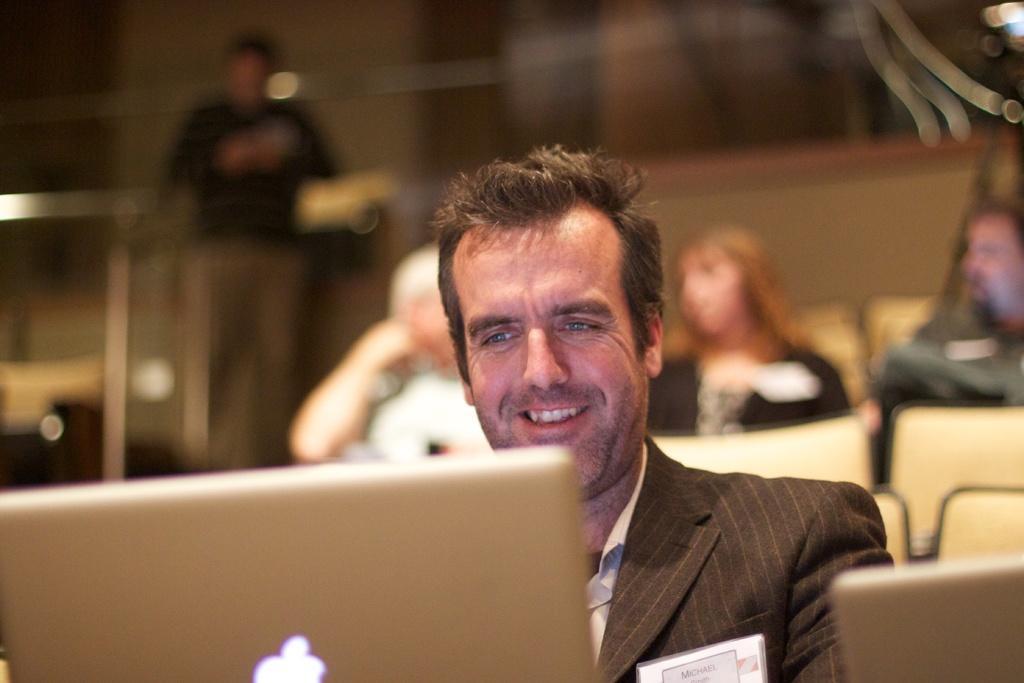How would you summarize this image in a sentence or two? In the center of the image there is a person sitting on the chair at the laptop. In the background we can see persons, chairs and wall. 